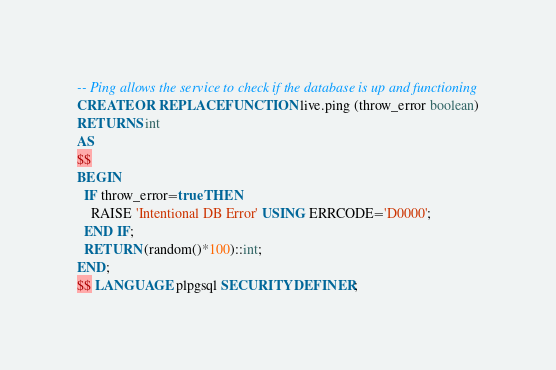Convert code to text. <code><loc_0><loc_0><loc_500><loc_500><_SQL_>-- Ping allows the service to check if the database is up and functioning
CREATE OR REPLACE FUNCTION live.ping (throw_error boolean)
RETURNS int
AS
$$
BEGIN
  IF throw_error=true THEN
    RAISE 'Intentional DB Error' USING ERRCODE='D0000';
  END IF;
  RETURN (random()*100)::int;
END;
$$ LANGUAGE plpgsql SECURITY DEFINER;
</code> 